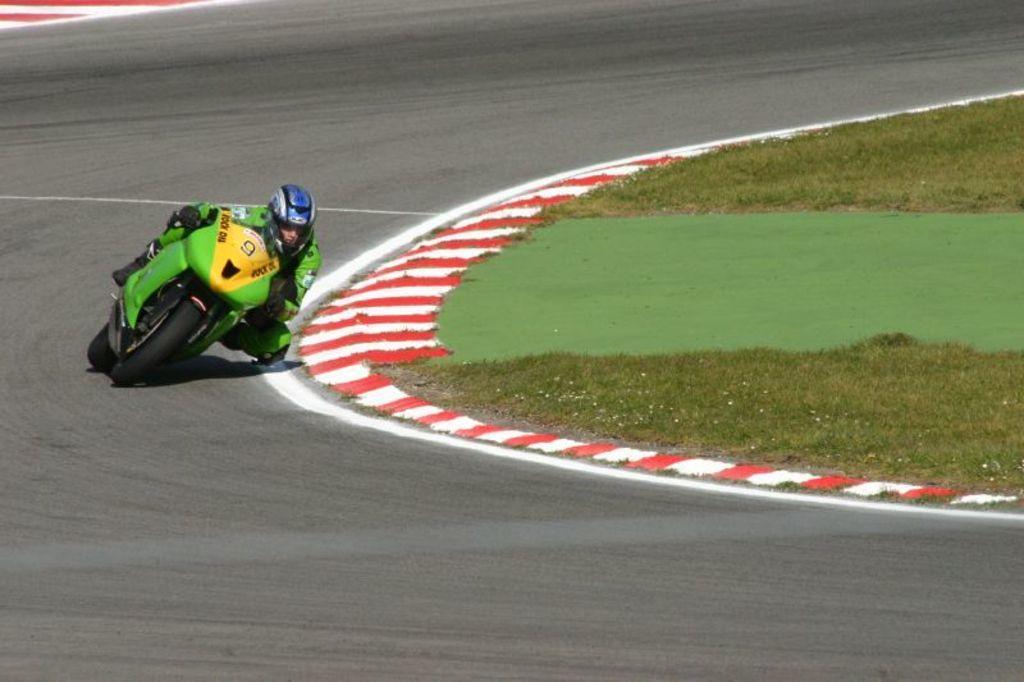Can you describe this image briefly? In this image we can see a person wearing helmet and gloves. And he is riding a motorcycle on the road. On the ground there is grass. 